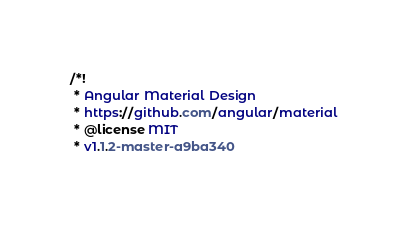Convert code to text. <code><loc_0><loc_0><loc_500><loc_500><_CSS_>/*!
 * Angular Material Design
 * https://github.com/angular/material
 * @license MIT
 * v1.1.2-master-a9ba340</code> 